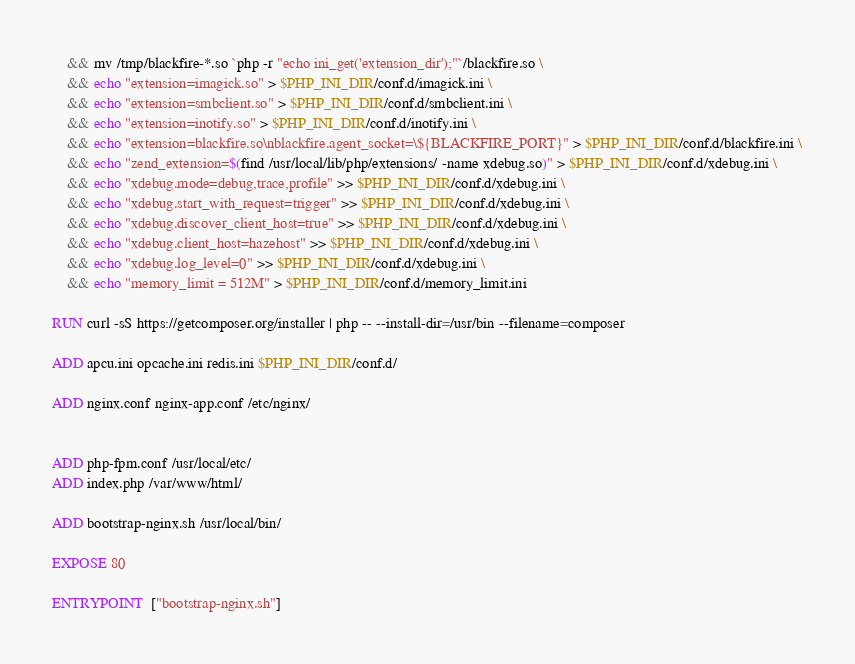Convert code to text. <code><loc_0><loc_0><loc_500><loc_500><_Dockerfile_>    && mv /tmp/blackfire-*.so `php -r "echo ini_get('extension_dir');"`/blackfire.so \
    && echo "extension=imagick.so" > $PHP_INI_DIR/conf.d/imagick.ini \
    && echo "extension=smbclient.so" > $PHP_INI_DIR/conf.d/smbclient.ini \
    && echo "extension=inotify.so" > $PHP_INI_DIR/conf.d/inotify.ini \
    && echo "extension=blackfire.so\nblackfire.agent_socket=\${BLACKFIRE_PORT}" > $PHP_INI_DIR/conf.d/blackfire.ini \
    && echo "zend_extension=$(find /usr/local/lib/php/extensions/ -name xdebug.so)" > $PHP_INI_DIR/conf.d/xdebug.ini \
    && echo "xdebug.mode=debug,trace,profile" >> $PHP_INI_DIR/conf.d/xdebug.ini \
    && echo "xdebug.start_with_request=trigger" >> $PHP_INI_DIR/conf.d/xdebug.ini \
    && echo "xdebug.discover_client_host=true" >> $PHP_INI_DIR/conf.d/xdebug.ini \
    && echo "xdebug.client_host=hazehost" >> $PHP_INI_DIR/conf.d/xdebug.ini \
    && echo "xdebug.log_level=0" >> $PHP_INI_DIR/conf.d/xdebug.ini \
    && echo "memory_limit = 512M" > $PHP_INI_DIR/conf.d/memory_limit.ini

RUN curl -sS https://getcomposer.org/installer | php -- --install-dir=/usr/bin --filename=composer

ADD apcu.ini opcache.ini redis.ini $PHP_INI_DIR/conf.d/

ADD nginx.conf nginx-app.conf /etc/nginx/


ADD php-fpm.conf /usr/local/etc/
ADD index.php /var/www/html/

ADD bootstrap-nginx.sh /usr/local/bin/

EXPOSE 80

ENTRYPOINT  ["bootstrap-nginx.sh"]
</code> 